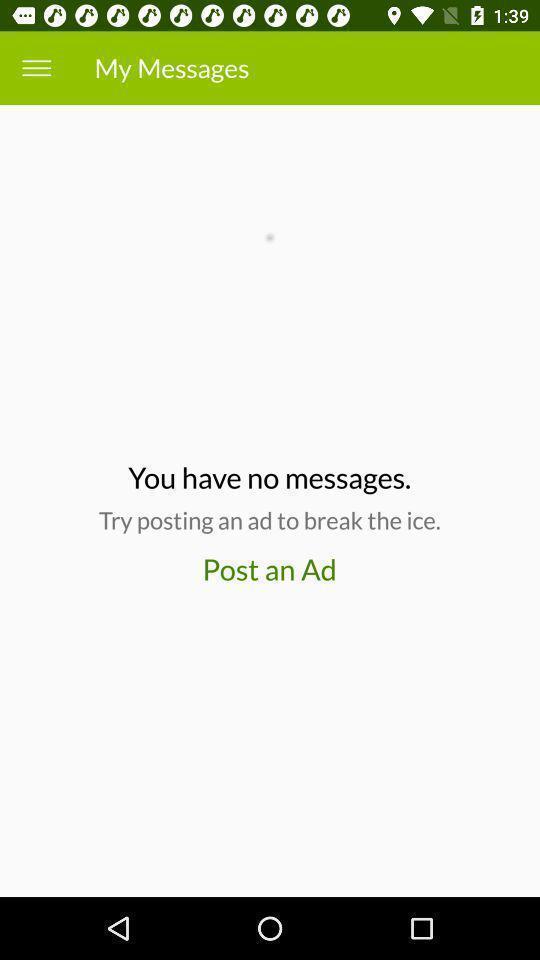Tell me about the visual elements in this screen capture. Page showing you have no messages in my messages. 